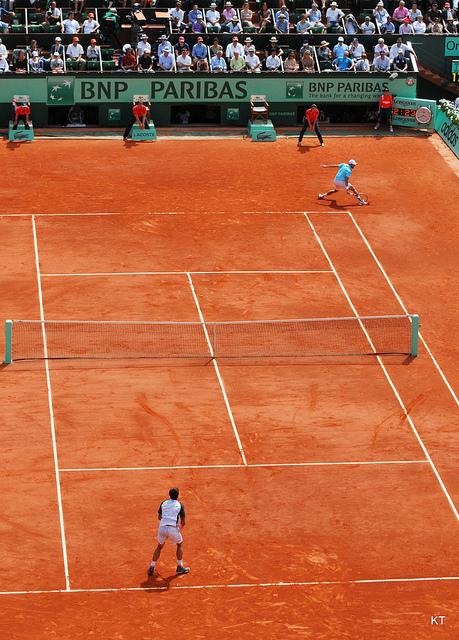Are there spectators?
Be succinct. Yes. What sport are they playing?
Be succinct. Tennis. What color is the court?
Short answer required. Orange. 